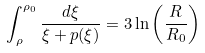<formula> <loc_0><loc_0><loc_500><loc_500>\int _ { \rho } ^ { \rho _ { 0 } } \frac { d \xi } { \xi + p ( \xi ) } = 3 \ln \left ( \frac { R } { R _ { 0 } } \right )</formula> 